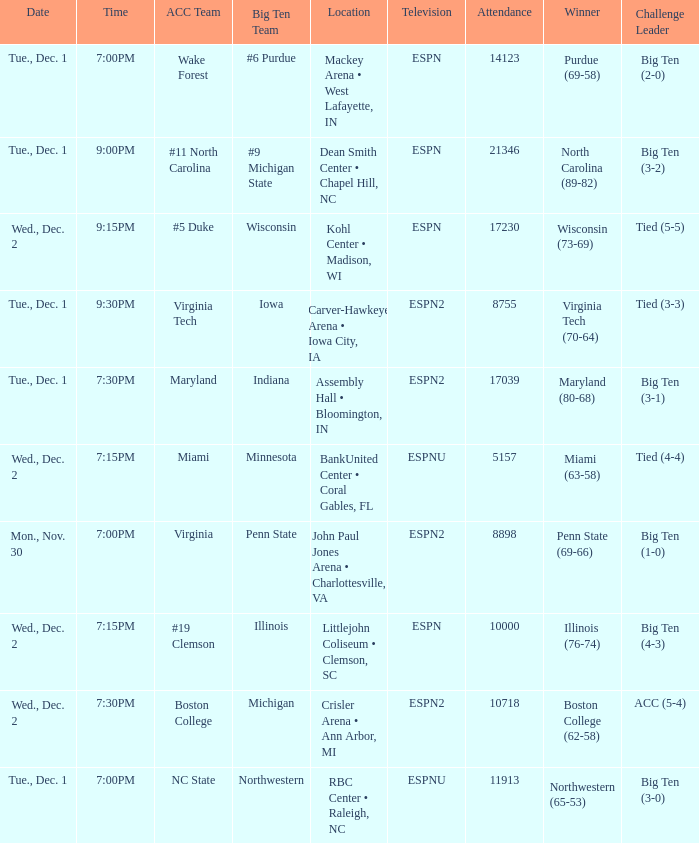Name the location for illinois Littlejohn Coliseum • Clemson, SC. 